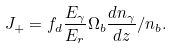<formula> <loc_0><loc_0><loc_500><loc_500>J _ { + } = f _ { d } \frac { E _ { \gamma } } { E _ { r } } \Omega _ { b } \frac { d n _ { \gamma } } { d z } / n _ { b } .</formula> 